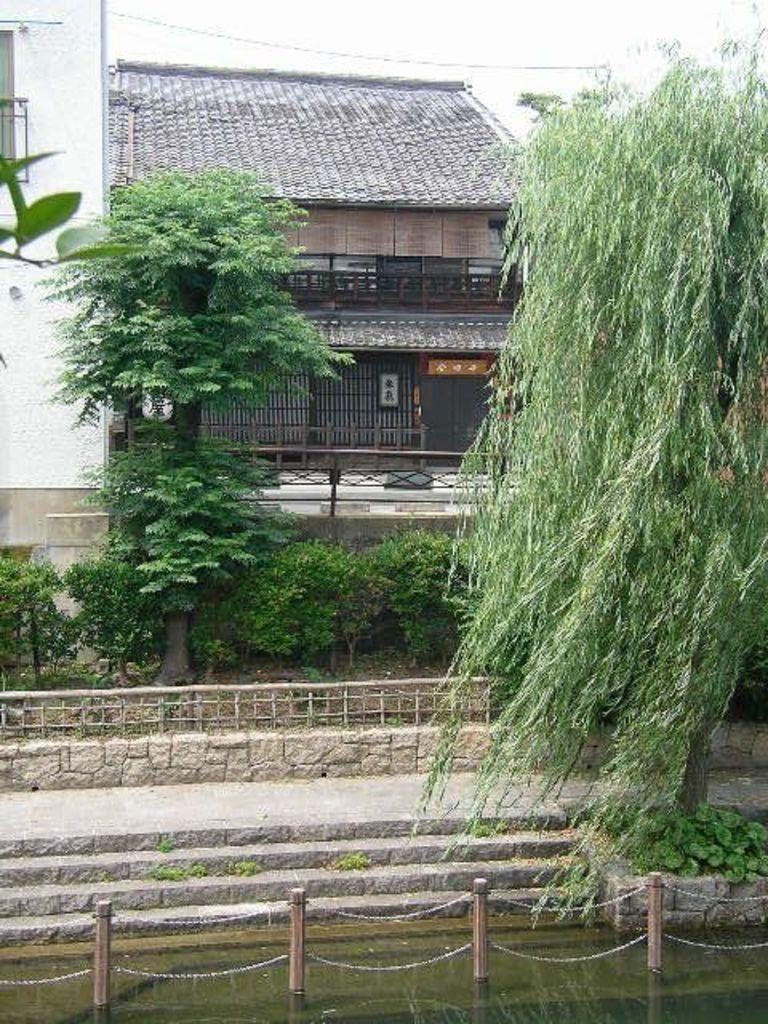What type of structure is visible in the image? There is a house in the image. What natural elements can be seen in the image? There are trees and plants visible in the image. Are there any architectural features in the image? Yes, there are stairs in the image. Can you describe the water in the image? There is water visible in the image. What other objects can be seen in the image? There are poles, chains, a fence, and electric wires in the image. How would you describe the sky in the image? The sky is white in the image. How many faces can be seen on the house in the image? There are no faces visible on the house in the image. What type of rose is growing near the fence in the image? There are no roses present in the image. 